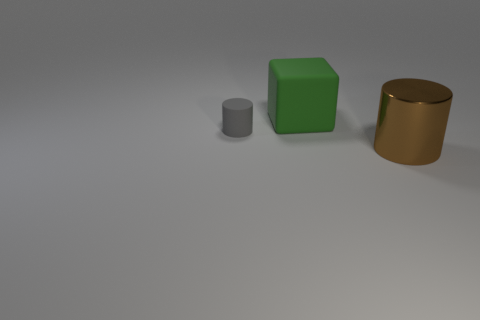Add 1 large brown cylinders. How many objects exist? 4 Subtract all cubes. How many objects are left? 2 Add 1 large cubes. How many large cubes are left? 2 Add 1 rubber cylinders. How many rubber cylinders exist? 2 Subtract 0 red cubes. How many objects are left? 3 Subtract all small matte objects. Subtract all large brown metallic cylinders. How many objects are left? 1 